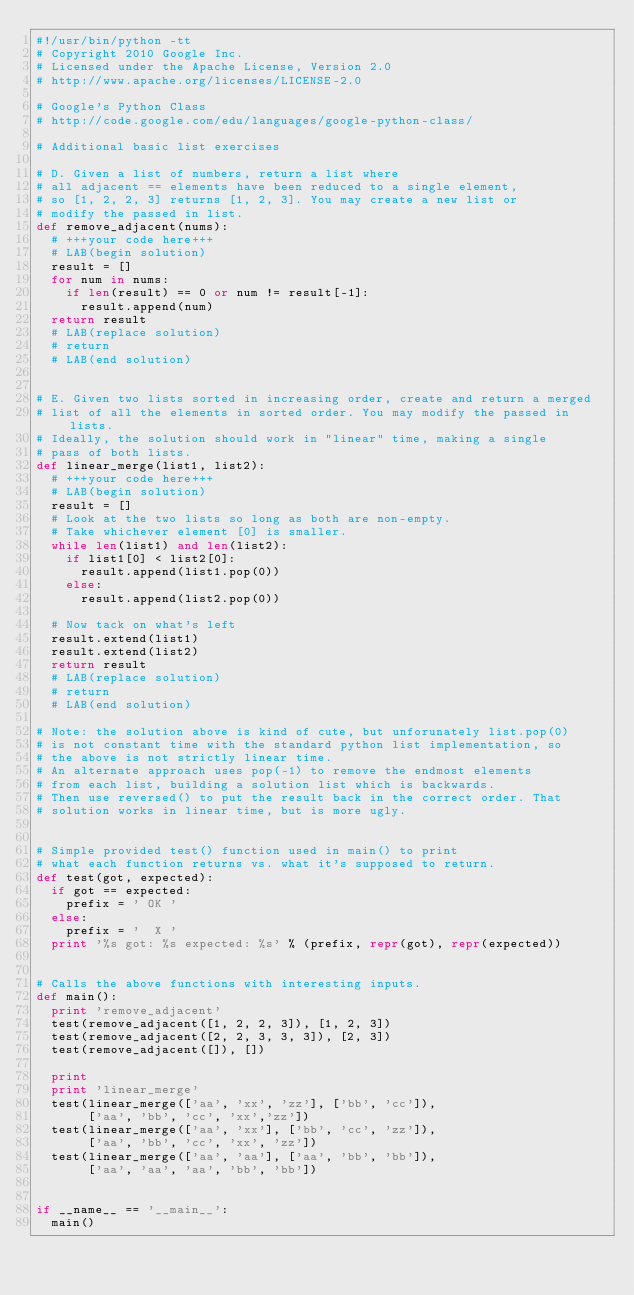Convert code to text. <code><loc_0><loc_0><loc_500><loc_500><_Python_>#!/usr/bin/python -tt
# Copyright 2010 Google Inc.
# Licensed under the Apache License, Version 2.0
# http://www.apache.org/licenses/LICENSE-2.0

# Google's Python Class
# http://code.google.com/edu/languages/google-python-class/

# Additional basic list exercises

# D. Given a list of numbers, return a list where
# all adjacent == elements have been reduced to a single element,
# so [1, 2, 2, 3] returns [1, 2, 3]. You may create a new list or
# modify the passed in list.
def remove_adjacent(nums):
  # +++your code here+++
  # LAB(begin solution)
  result = []
  for num in nums:
    if len(result) == 0 or num != result[-1]:
      result.append(num)
  return result
  # LAB(replace solution)
  # return
  # LAB(end solution)


# E. Given two lists sorted in increasing order, create and return a merged
# list of all the elements in sorted order. You may modify the passed in lists.
# Ideally, the solution should work in "linear" time, making a single
# pass of both lists.
def linear_merge(list1, list2):
  # +++your code here+++
  # LAB(begin solution)
  result = []
  # Look at the two lists so long as both are non-empty.
  # Take whichever element [0] is smaller.
  while len(list1) and len(list2):
    if list1[0] < list2[0]:
      result.append(list1.pop(0))
    else:
      result.append(list2.pop(0))

  # Now tack on what's left
  result.extend(list1)
  result.extend(list2)
  return result
  # LAB(replace solution)
  # return
  # LAB(end solution)

# Note: the solution above is kind of cute, but unforunately list.pop(0)
# is not constant time with the standard python list implementation, so
# the above is not strictly linear time.
# An alternate approach uses pop(-1) to remove the endmost elements
# from each list, building a solution list which is backwards.
# Then use reversed() to put the result back in the correct order. That
# solution works in linear time, but is more ugly.


# Simple provided test() function used in main() to print
# what each function returns vs. what it's supposed to return.
def test(got, expected):
  if got == expected:
    prefix = ' OK '
  else:
    prefix = '  X '
  print '%s got: %s expected: %s' % (prefix, repr(got), repr(expected))


# Calls the above functions with interesting inputs.
def main():
  print 'remove_adjacent'
  test(remove_adjacent([1, 2, 2, 3]), [1, 2, 3])
  test(remove_adjacent([2, 2, 3, 3, 3]), [2, 3])
  test(remove_adjacent([]), [])

  print
  print 'linear_merge'
  test(linear_merge(['aa', 'xx', 'zz'], ['bb', 'cc']),
       ['aa', 'bb', 'cc', 'xx','zz'])
  test(linear_merge(['aa', 'xx'], ['bb', 'cc', 'zz']),
       ['aa', 'bb', 'cc', 'xx', 'zz'])
  test(linear_merge(['aa', 'aa'], ['aa', 'bb', 'bb']),
       ['aa', 'aa', 'aa', 'bb', 'bb'])


if __name__ == '__main__':
  main()
</code> 